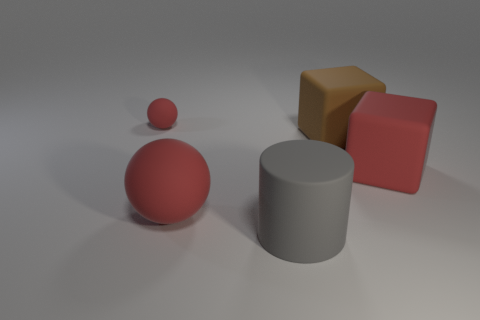Add 2 green blocks. How many objects exist? 7 Subtract all cylinders. How many objects are left? 4 Subtract 0 yellow balls. How many objects are left? 5 Subtract all big red matte cubes. Subtract all large brown blocks. How many objects are left? 3 Add 4 large red matte objects. How many large red matte objects are left? 6 Add 5 spheres. How many spheres exist? 7 